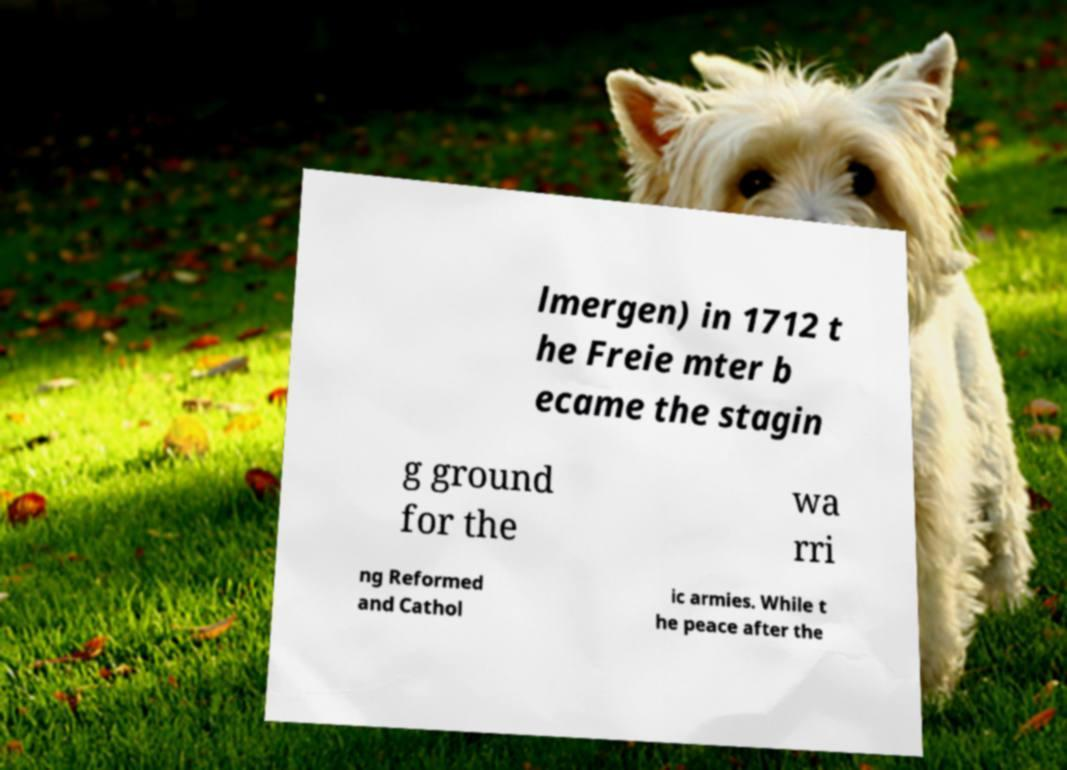Please read and relay the text visible in this image. What does it say? lmergen) in 1712 t he Freie mter b ecame the stagin g ground for the wa rri ng Reformed and Cathol ic armies. While t he peace after the 